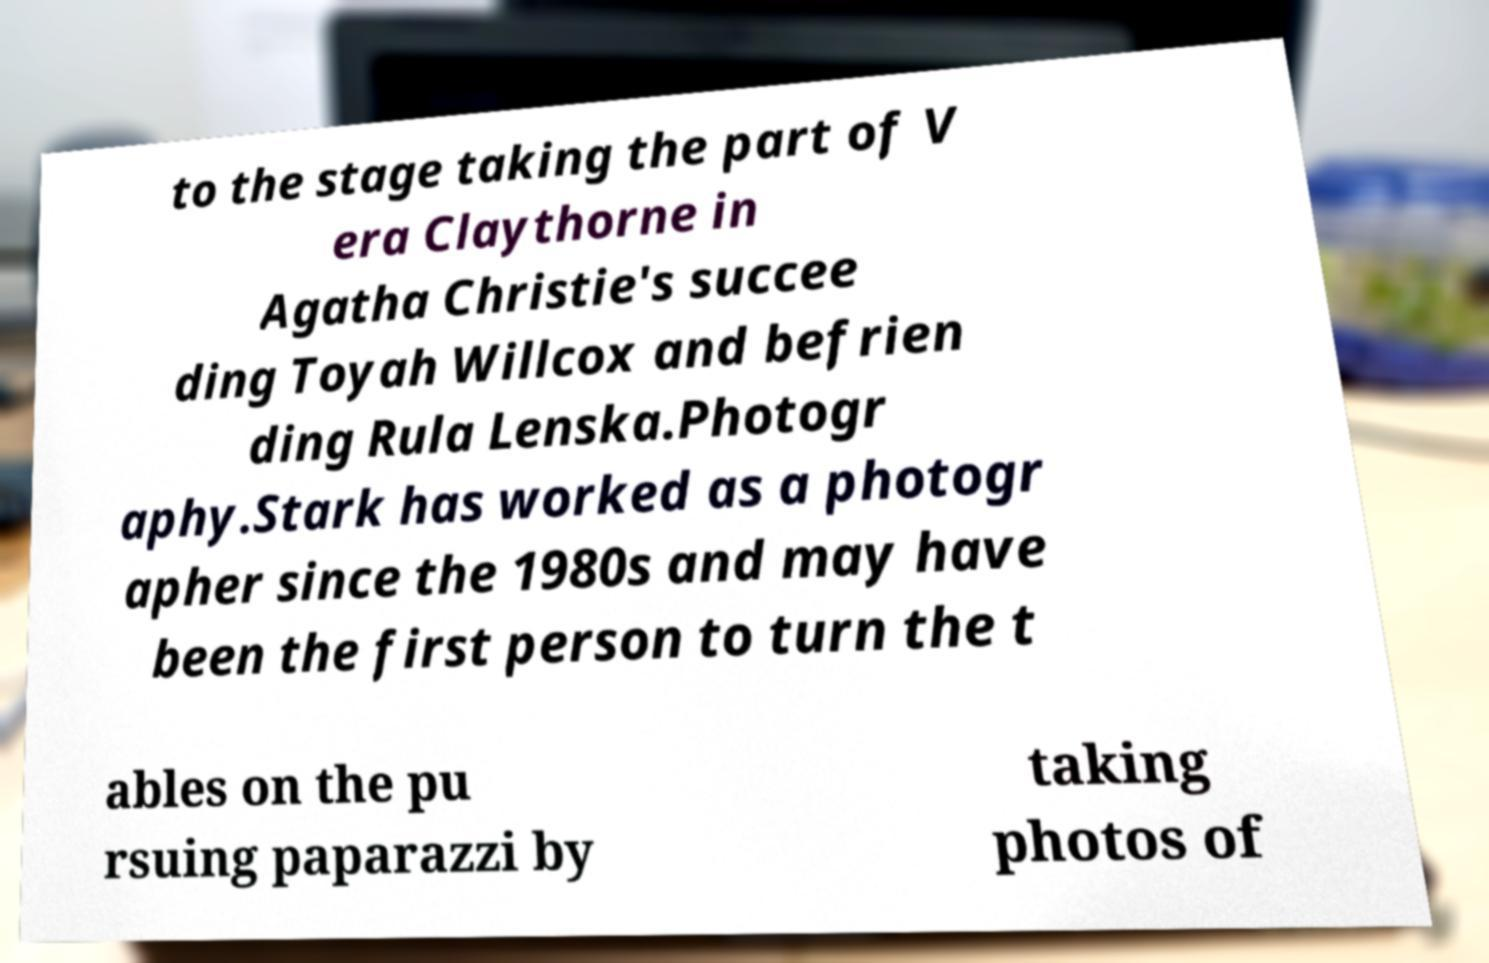Please read and relay the text visible in this image. What does it say? to the stage taking the part of V era Claythorne in Agatha Christie's succee ding Toyah Willcox and befrien ding Rula Lenska.Photogr aphy.Stark has worked as a photogr apher since the 1980s and may have been the first person to turn the t ables on the pu rsuing paparazzi by taking photos of 